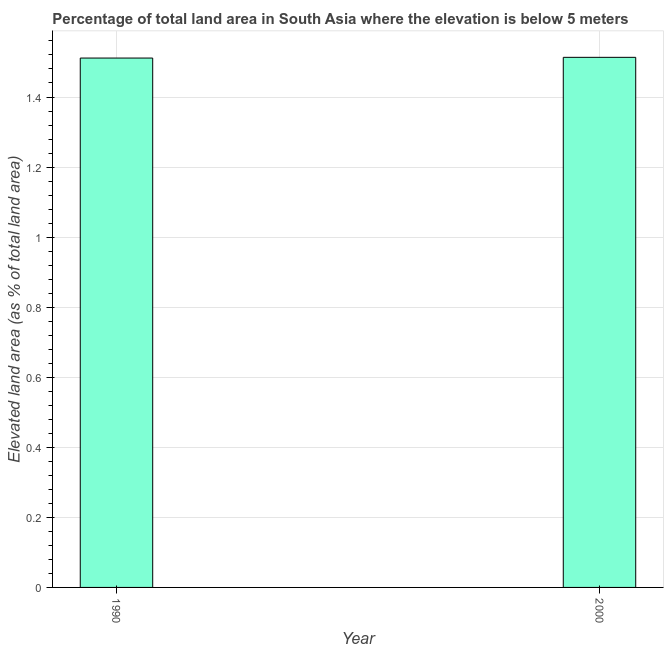Does the graph contain any zero values?
Your response must be concise. No. Does the graph contain grids?
Provide a succinct answer. Yes. What is the title of the graph?
Your answer should be very brief. Percentage of total land area in South Asia where the elevation is below 5 meters. What is the label or title of the X-axis?
Keep it short and to the point. Year. What is the label or title of the Y-axis?
Provide a short and direct response. Elevated land area (as % of total land area). What is the total elevated land area in 2000?
Keep it short and to the point. 1.51. Across all years, what is the maximum total elevated land area?
Make the answer very short. 1.51. Across all years, what is the minimum total elevated land area?
Offer a terse response. 1.51. In which year was the total elevated land area minimum?
Keep it short and to the point. 1990. What is the sum of the total elevated land area?
Provide a succinct answer. 3.02. What is the difference between the total elevated land area in 1990 and 2000?
Provide a short and direct response. -0. What is the average total elevated land area per year?
Give a very brief answer. 1.51. What is the median total elevated land area?
Your answer should be compact. 1.51. In how many years, is the total elevated land area greater than 1.4 %?
Ensure brevity in your answer.  2. What is the ratio of the total elevated land area in 1990 to that in 2000?
Keep it short and to the point. 1. Is the total elevated land area in 1990 less than that in 2000?
Provide a succinct answer. Yes. In how many years, is the total elevated land area greater than the average total elevated land area taken over all years?
Make the answer very short. 1. What is the Elevated land area (as % of total land area) in 1990?
Your answer should be compact. 1.51. What is the Elevated land area (as % of total land area) in 2000?
Keep it short and to the point. 1.51. What is the difference between the Elevated land area (as % of total land area) in 1990 and 2000?
Provide a succinct answer. -0. What is the ratio of the Elevated land area (as % of total land area) in 1990 to that in 2000?
Your response must be concise. 1. 